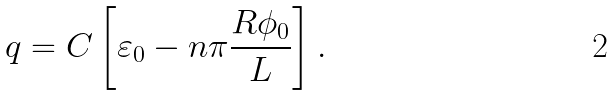<formula> <loc_0><loc_0><loc_500><loc_500>q = C \left [ \varepsilon _ { 0 } - n \pi \frac { R \phi _ { 0 } } { L } \right ] .</formula> 